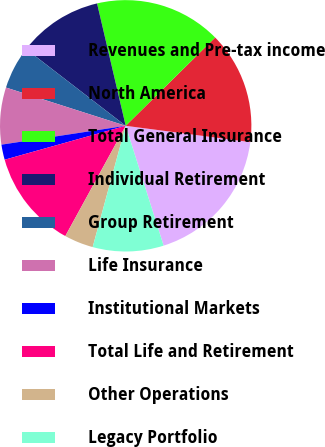Convert chart. <chart><loc_0><loc_0><loc_500><loc_500><pie_chart><fcel>Revenues and Pre-tax income<fcel>North America<fcel>Total General Insurance<fcel>Individual Retirement<fcel>Group Retirement<fcel>Life Insurance<fcel>Institutional Markets<fcel>Total Life and Retirement<fcel>Other Operations<fcel>Legacy Portfolio<nl><fcel>18.05%<fcel>14.47%<fcel>16.26%<fcel>10.89%<fcel>5.53%<fcel>7.32%<fcel>1.95%<fcel>12.68%<fcel>3.74%<fcel>9.11%<nl></chart> 